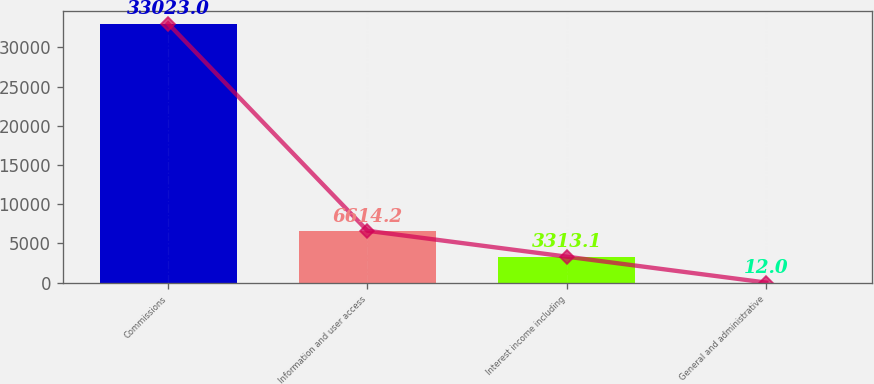Convert chart. <chart><loc_0><loc_0><loc_500><loc_500><bar_chart><fcel>Commissions<fcel>Information and user access<fcel>Interest income including<fcel>General and administrative<nl><fcel>33023<fcel>6614.2<fcel>3313.1<fcel>12<nl></chart> 